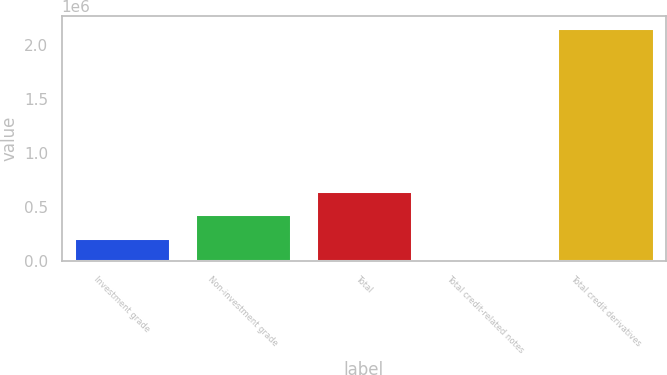<chart> <loc_0><loc_0><loc_500><loc_500><bar_chart><fcel>Investment grade<fcel>Non-investment grade<fcel>Total<fcel>Total credit-related notes<fcel>Total credit derivatives<nl><fcel>218851<fcel>434085<fcel>649320<fcel>3616<fcel>2.15596e+06<nl></chart> 